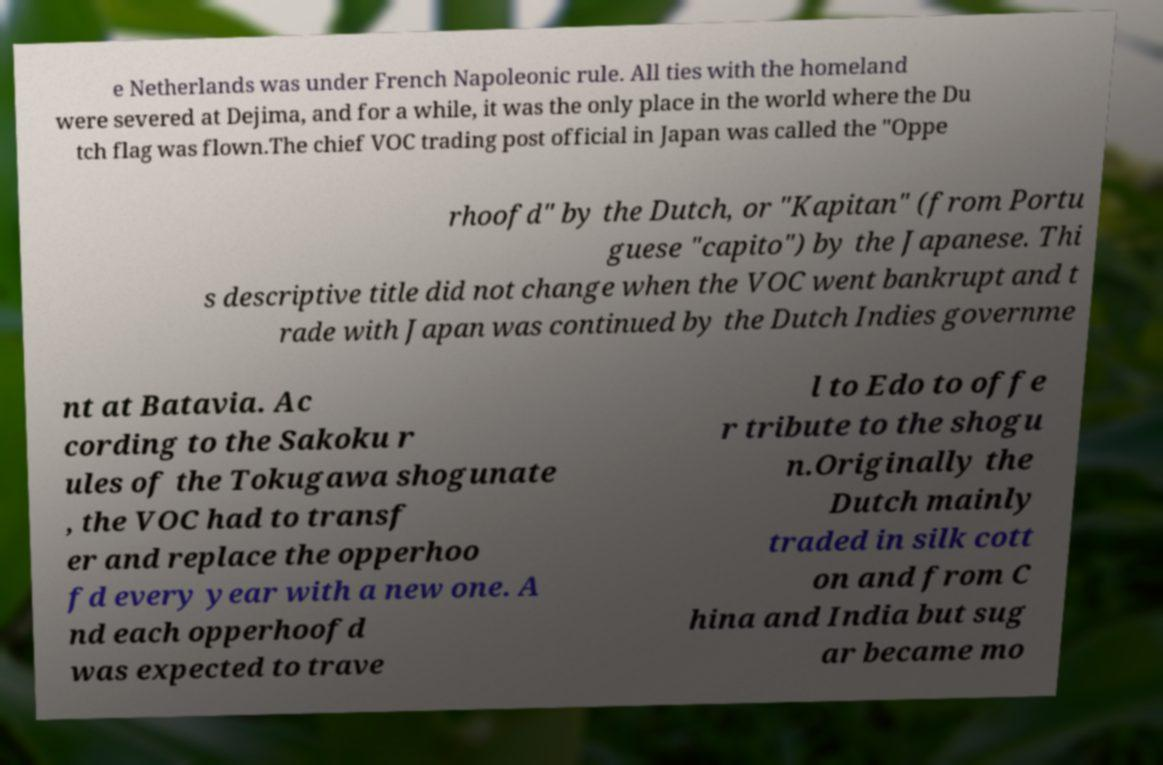There's text embedded in this image that I need extracted. Can you transcribe it verbatim? e Netherlands was under French Napoleonic rule. All ties with the homeland were severed at Dejima, and for a while, it was the only place in the world where the Du tch flag was flown.The chief VOC trading post official in Japan was called the "Oppe rhoofd" by the Dutch, or "Kapitan" (from Portu guese "capito") by the Japanese. Thi s descriptive title did not change when the VOC went bankrupt and t rade with Japan was continued by the Dutch Indies governme nt at Batavia. Ac cording to the Sakoku r ules of the Tokugawa shogunate , the VOC had to transf er and replace the opperhoo fd every year with a new one. A nd each opperhoofd was expected to trave l to Edo to offe r tribute to the shogu n.Originally the Dutch mainly traded in silk cott on and from C hina and India but sug ar became mo 